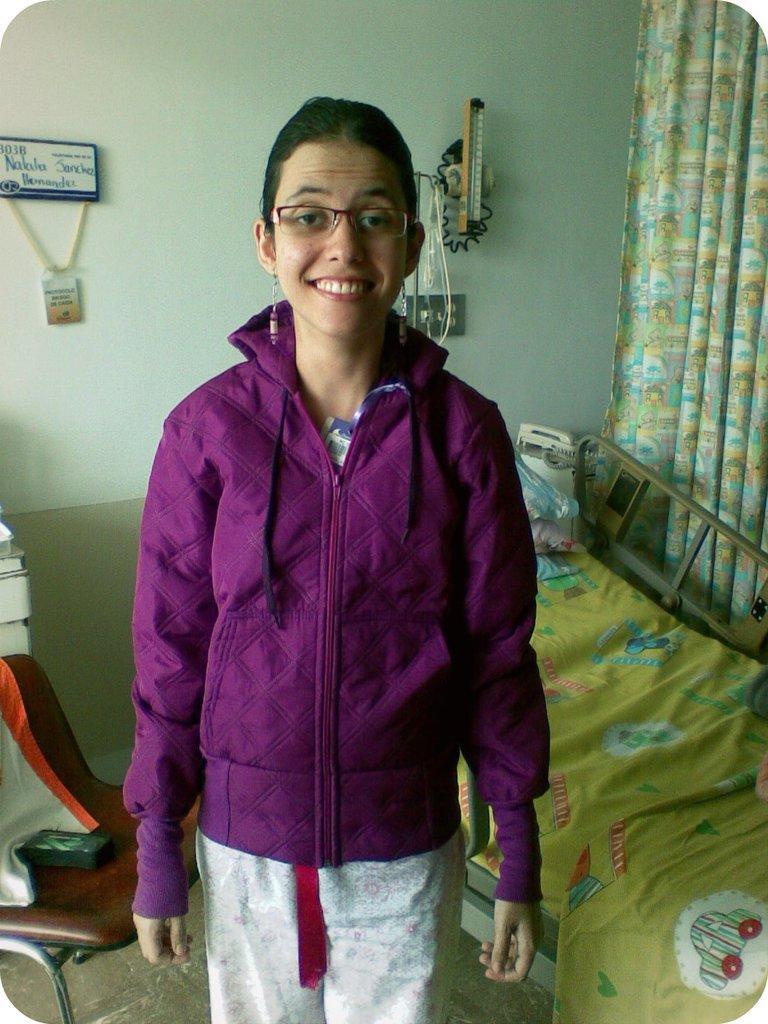Please provide a concise description of this image. In the middle a girl is standing, she wore purple color sweater and also smiling. On the right side there is a bed, on the left side there is a chair behind her there is the wall. 